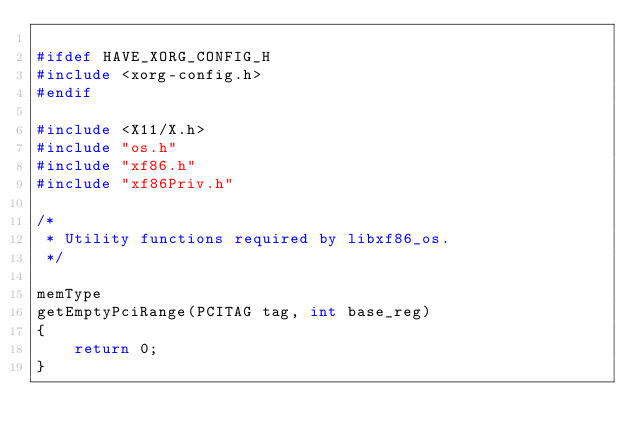Convert code to text. <code><loc_0><loc_0><loc_500><loc_500><_C_>
#ifdef HAVE_XORG_CONFIG_H
#include <xorg-config.h>
#endif

#include <X11/X.h>
#include "os.h"
#include "xf86.h"
#include "xf86Priv.h"

/*
 * Utility functions required by libxf86_os. 
 */

memType
getEmptyPciRange(PCITAG tag, int base_reg)
{
    return 0;
}
</code> 